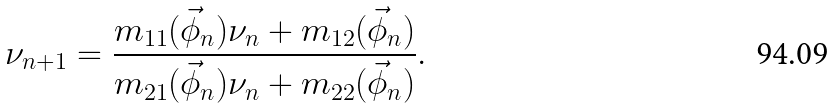Convert formula to latex. <formula><loc_0><loc_0><loc_500><loc_500>\nu _ { n + 1 } = \frac { m _ { 1 1 } ( \vec { \phi } _ { n } ) \nu _ { n } + m _ { 1 2 } ( \vec { \phi } _ { n } ) } { m _ { 2 1 } ( \vec { \phi } _ { n } ) \nu _ { n } + m _ { 2 2 } ( \vec { \phi } _ { n } ) } .</formula> 